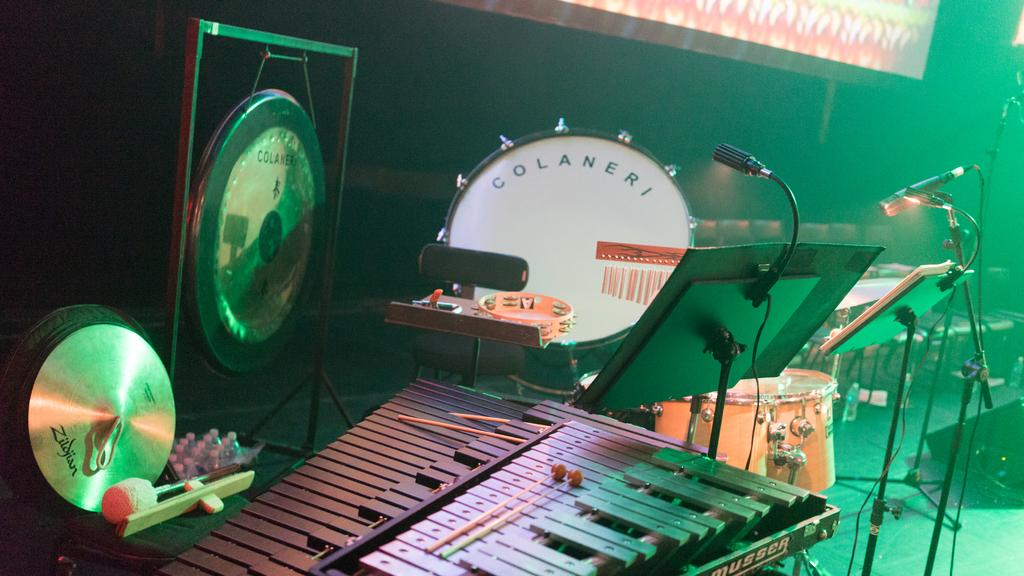What type of musical instrument is the main subject of the image? There is a vibraphone in the image. What other musical instruments can be seen in the image? There are drums and a tambourine in the image, as well as other musical instruments. What equipment is present to support the musicians? There are music stands and microphones attached to microphone stands in the image. How many frogs are sitting on the vibraphone in the image? There are no frogs present in the image; it features musical instruments and equipment. What is the best way to transport the vibraphone in the image? The image does not provide information on how to transport the vibraphone, as it only shows the instrument and other equipment in a stationary setting. 